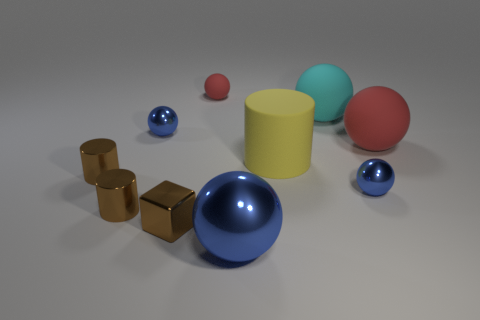Does the tiny metal object on the right side of the brown metallic cube have the same color as the large metallic object?
Your answer should be very brief. Yes. What number of balls are to the right of the cyan ball and in front of the large yellow rubber cylinder?
Your answer should be very brief. 1. The cyan matte thing that is the same shape as the big red matte thing is what size?
Offer a terse response. Large. There is a red thing to the right of the shiny object that is to the right of the cyan rubber ball; what number of metal cylinders are behind it?
Offer a terse response. 0. What is the color of the metallic sphere that is to the left of the red ball that is left of the big yellow cylinder?
Offer a terse response. Blue. How many other objects are the same material as the large cylinder?
Provide a short and direct response. 3. There is a small blue thing in front of the big red matte sphere; what number of tiny blue metallic spheres are to the left of it?
Provide a short and direct response. 1. Is the color of the tiny thing right of the big cyan rubber sphere the same as the large object in front of the big yellow matte thing?
Offer a very short reply. Yes. Is the number of big red shiny blocks less than the number of metallic things?
Provide a short and direct response. Yes. The shiny thing that is right of the cyan sphere on the right side of the small rubber object is what shape?
Offer a very short reply. Sphere. 